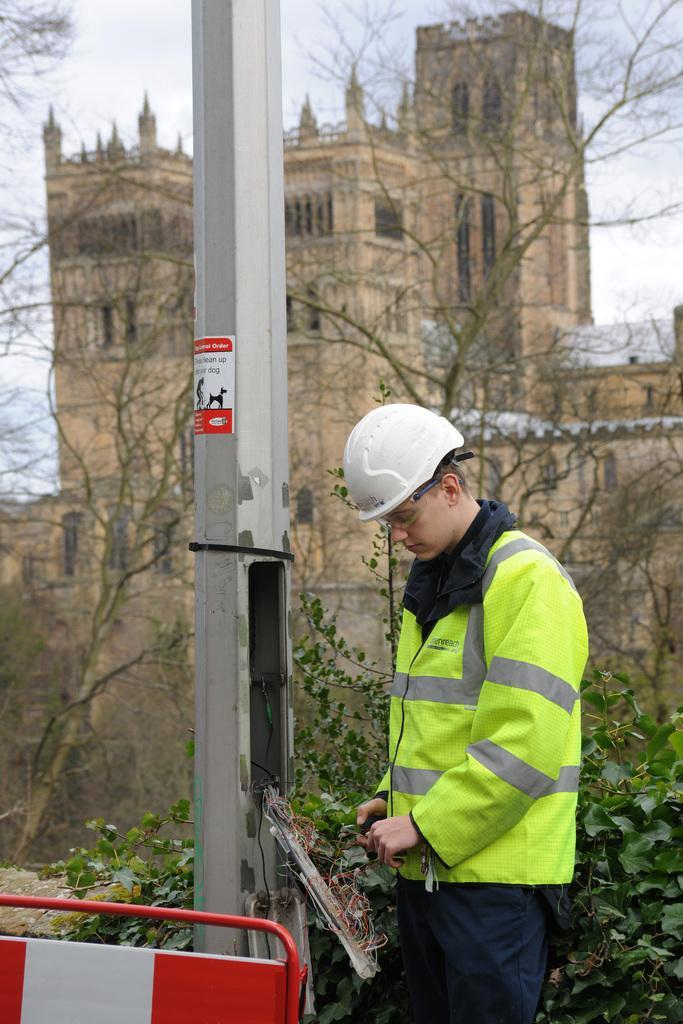Describe this image in one or two sentences. In the foreground of the picture there are pole, barricade and a person wearing helmet and working with the wires. In the center of the picture there are plants and trees. In the background there is a construction. 